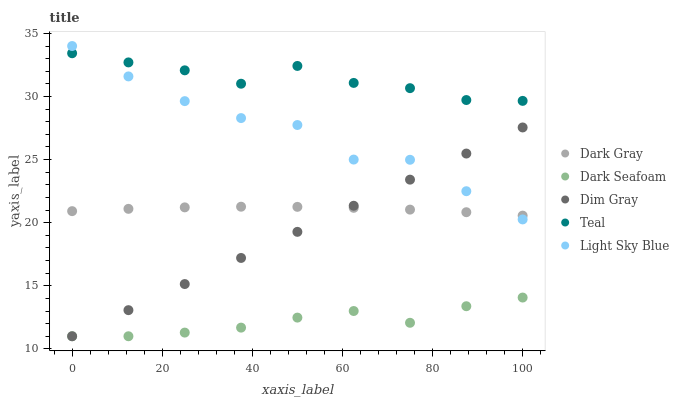Does Dark Seafoam have the minimum area under the curve?
Answer yes or no. Yes. Does Teal have the maximum area under the curve?
Answer yes or no. Yes. Does Dim Gray have the minimum area under the curve?
Answer yes or no. No. Does Dim Gray have the maximum area under the curve?
Answer yes or no. No. Is Dim Gray the smoothest?
Answer yes or no. Yes. Is Light Sky Blue the roughest?
Answer yes or no. Yes. Is Dark Seafoam the smoothest?
Answer yes or no. No. Is Dark Seafoam the roughest?
Answer yes or no. No. Does Dark Seafoam have the lowest value?
Answer yes or no. Yes. Does Teal have the lowest value?
Answer yes or no. No. Does Light Sky Blue have the highest value?
Answer yes or no. Yes. Does Dim Gray have the highest value?
Answer yes or no. No. Is Dark Seafoam less than Dark Gray?
Answer yes or no. Yes. Is Teal greater than Dim Gray?
Answer yes or no. Yes. Does Light Sky Blue intersect Dim Gray?
Answer yes or no. Yes. Is Light Sky Blue less than Dim Gray?
Answer yes or no. No. Is Light Sky Blue greater than Dim Gray?
Answer yes or no. No. Does Dark Seafoam intersect Dark Gray?
Answer yes or no. No. 